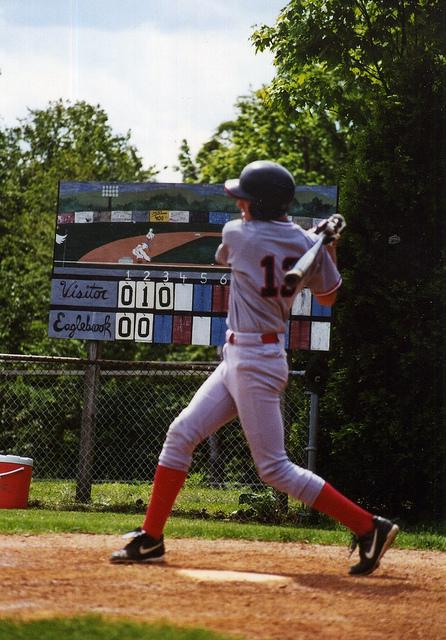Which team is winning? visitor 